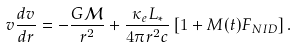Convert formula to latex. <formula><loc_0><loc_0><loc_500><loc_500>v \frac { d v } { d r } = - \frac { G \mathcal { M } } { r ^ { 2 } } + \frac { \kappa _ { e } L _ { * } } { 4 \pi r ^ { 2 } c } \left [ 1 + M ( t ) F _ { N I D } \right ] .</formula> 